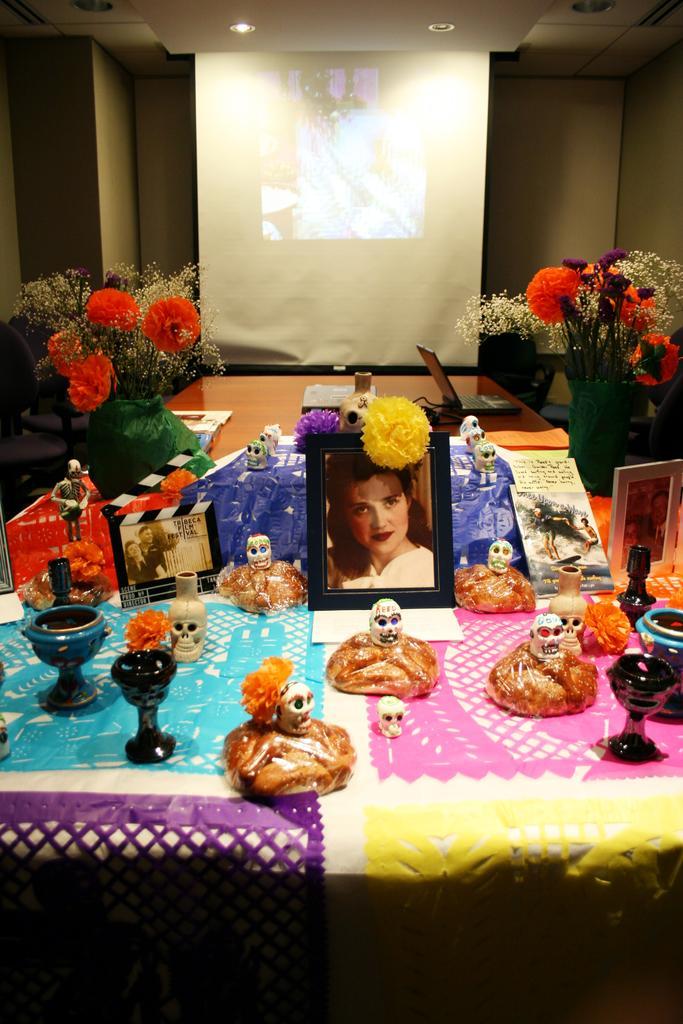Describe this image in one or two sentences. In this picture there is a photo frames on the table. Beside there are many skeleton toys and some cups. Behind we can see the red color flower pots. In the background there is a white projector screen. 